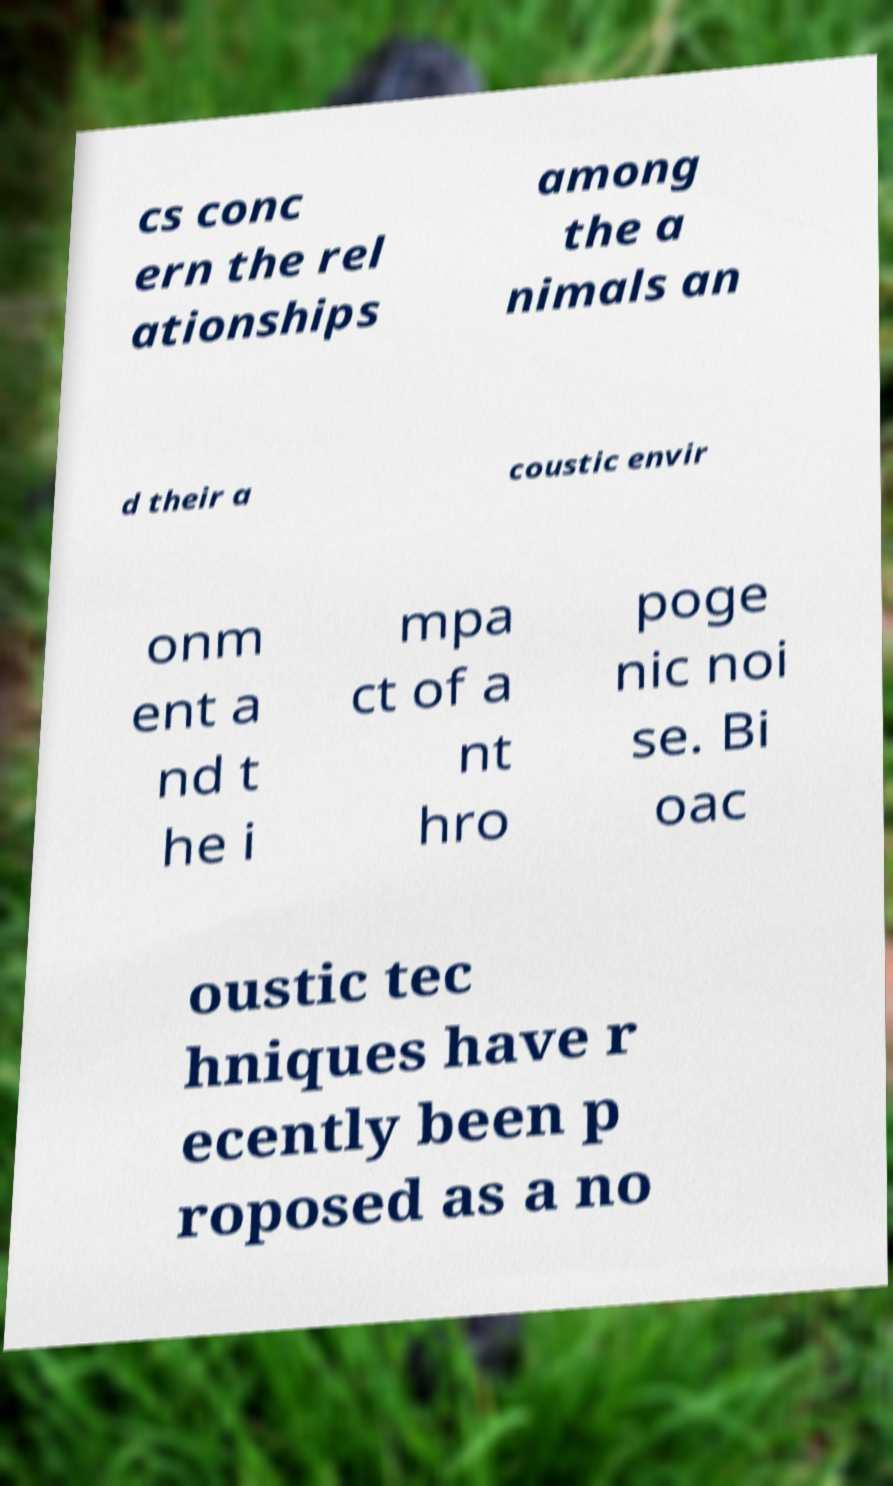I need the written content from this picture converted into text. Can you do that? cs conc ern the rel ationships among the a nimals an d their a coustic envir onm ent a nd t he i mpa ct of a nt hro poge nic noi se. Bi oac oustic tec hniques have r ecently been p roposed as a no 